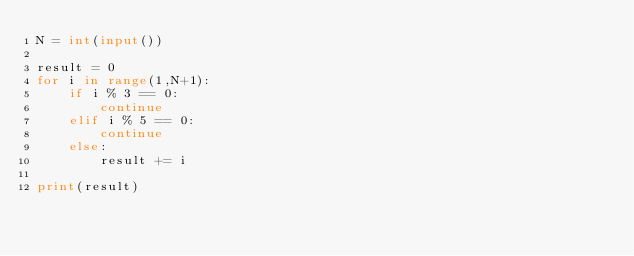Convert code to text. <code><loc_0><loc_0><loc_500><loc_500><_Python_>N = int(input())

result = 0
for i in range(1,N+1):
    if i % 3 == 0:
        continue
    elif i % 5 == 0:
        continue
    else:
        result += i
    
print(result)
</code> 